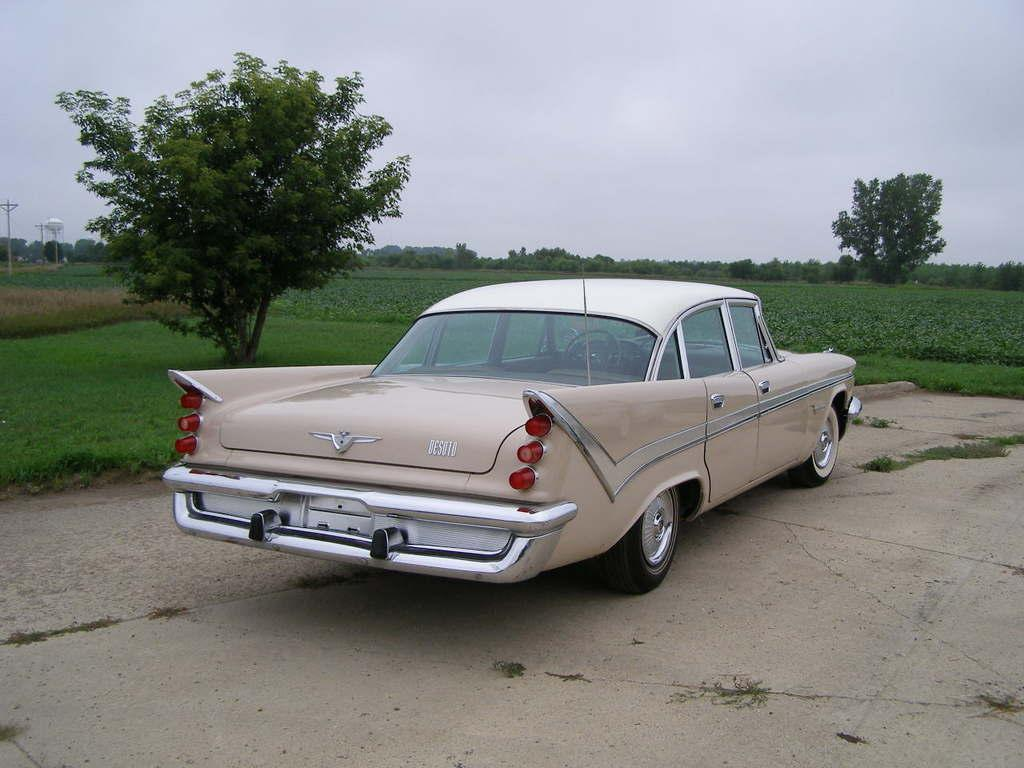What is the main subject in the image? There is a vehicle in the image. What can be seen beneath the vehicle? The ground is visible in the image. What type of vegetation is present in the image? There is grass, plants, and trees in the image. What are the poles used for in the image? The purpose of the poles is not specified, but they are visible in the image. What is visible in the background of the image? The sky is visible in the image. What is the color of the white colored object in the image? The white colored object in the image is not described in detail, so its color cannot be determined. What is the tendency of the dolls to move around in the image? There are no dolls present in the image, so their tendency to move cannot be determined. 